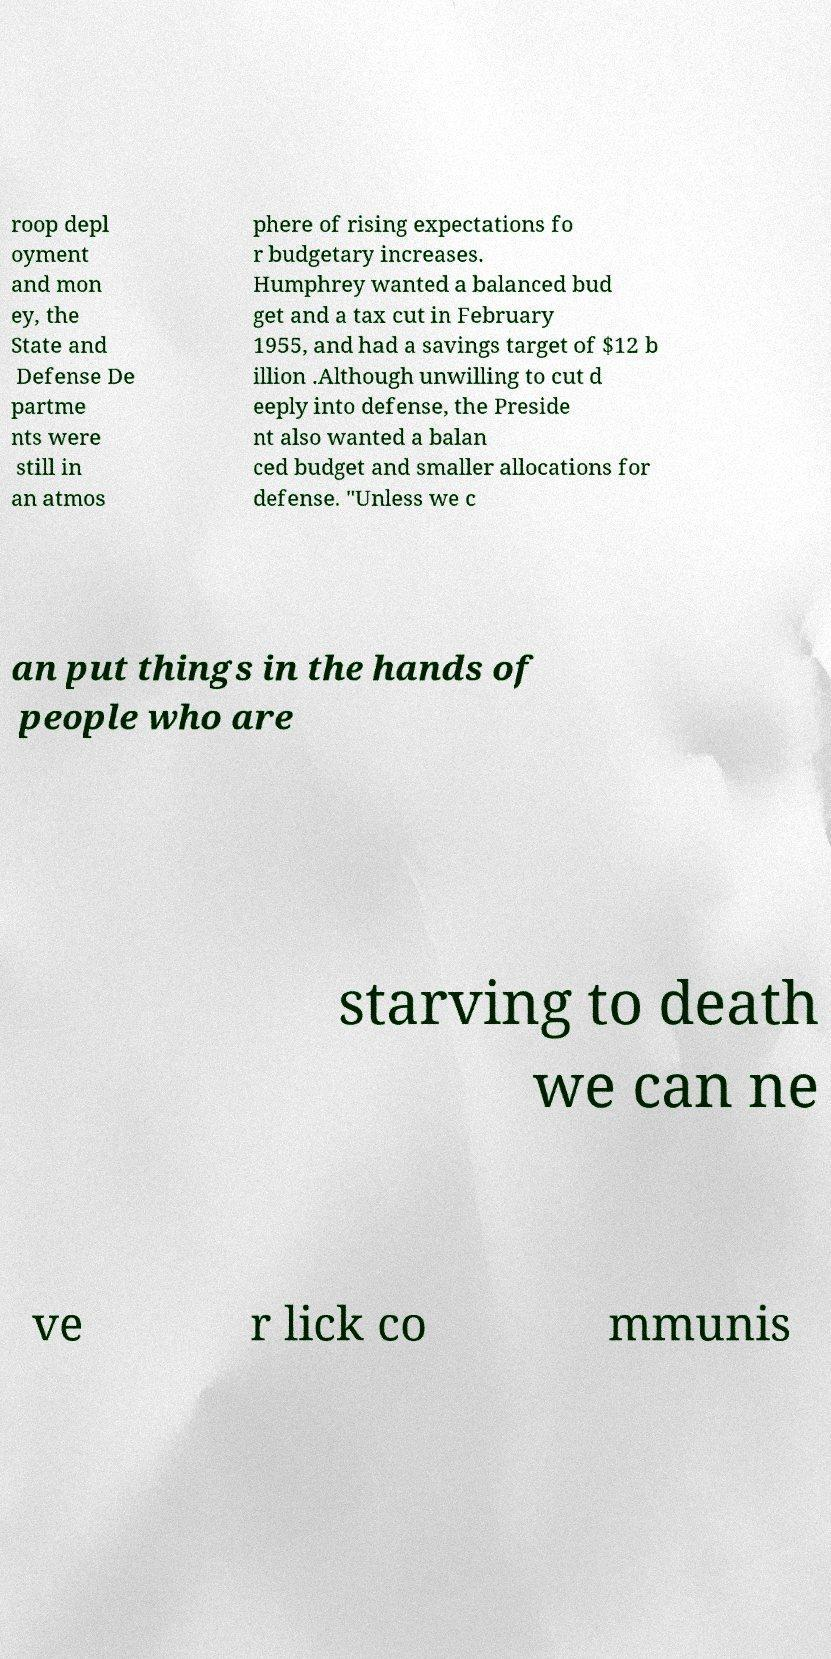I need the written content from this picture converted into text. Can you do that? roop depl oyment and mon ey, the State and Defense De partme nts were still in an atmos phere of rising expectations fo r budgetary increases. Humphrey wanted a balanced bud get and a tax cut in February 1955, and had a savings target of $12 b illion .Although unwilling to cut d eeply into defense, the Preside nt also wanted a balan ced budget and smaller allocations for defense. "Unless we c an put things in the hands of people who are starving to death we can ne ve r lick co mmunis 